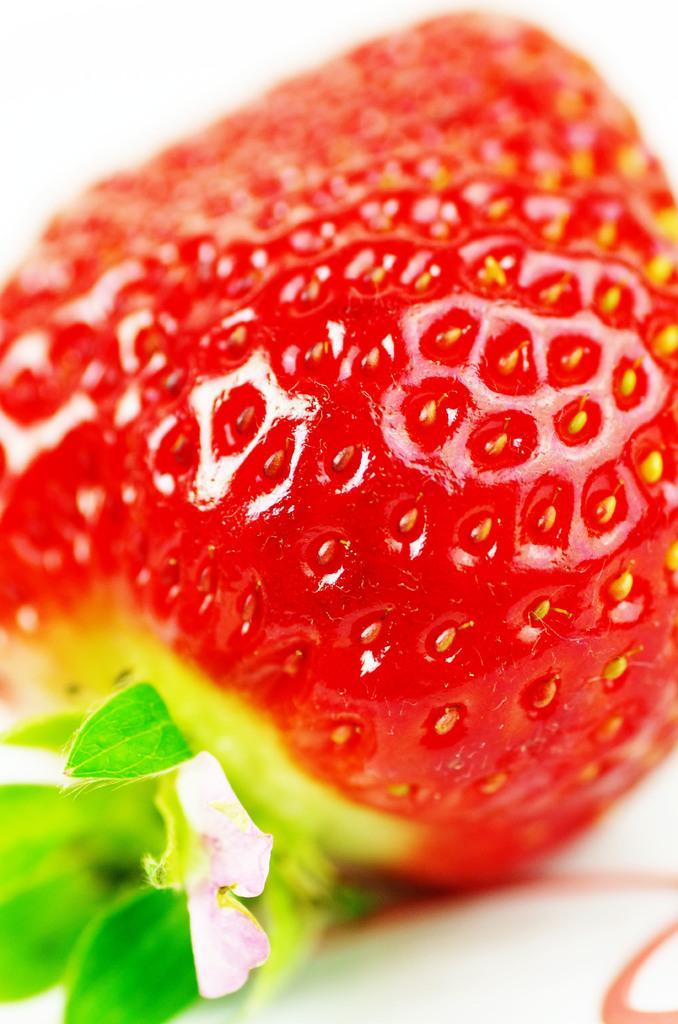Please provide a concise description of this image. In this image we can see a strawberry. 